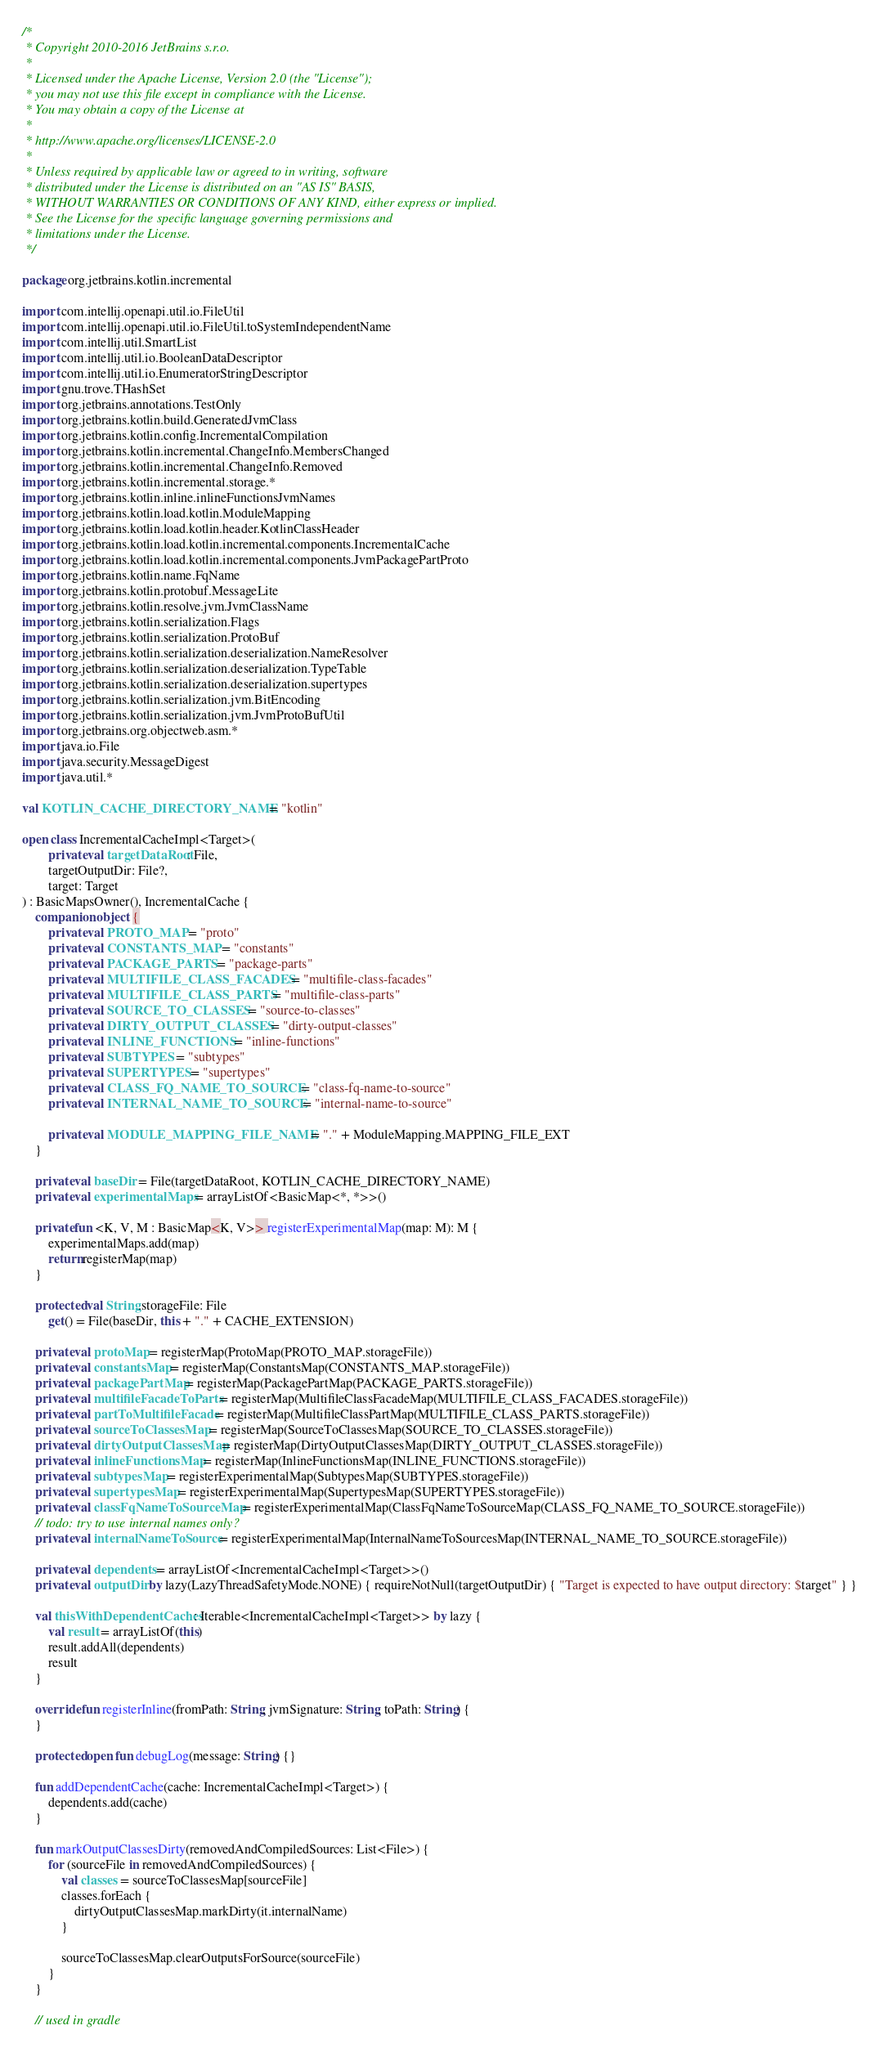Convert code to text. <code><loc_0><loc_0><loc_500><loc_500><_Kotlin_>/*
 * Copyright 2010-2016 JetBrains s.r.o.
 *
 * Licensed under the Apache License, Version 2.0 (the "License");
 * you may not use this file except in compliance with the License.
 * You may obtain a copy of the License at
 *
 * http://www.apache.org/licenses/LICENSE-2.0
 *
 * Unless required by applicable law or agreed to in writing, software
 * distributed under the License is distributed on an "AS IS" BASIS,
 * WITHOUT WARRANTIES OR CONDITIONS OF ANY KIND, either express or implied.
 * See the License for the specific language governing permissions and
 * limitations under the License.
 */

package org.jetbrains.kotlin.incremental

import com.intellij.openapi.util.io.FileUtil
import com.intellij.openapi.util.io.FileUtil.toSystemIndependentName
import com.intellij.util.SmartList
import com.intellij.util.io.BooleanDataDescriptor
import com.intellij.util.io.EnumeratorStringDescriptor
import gnu.trove.THashSet
import org.jetbrains.annotations.TestOnly
import org.jetbrains.kotlin.build.GeneratedJvmClass
import org.jetbrains.kotlin.config.IncrementalCompilation
import org.jetbrains.kotlin.incremental.ChangeInfo.MembersChanged
import org.jetbrains.kotlin.incremental.ChangeInfo.Removed
import org.jetbrains.kotlin.incremental.storage.*
import org.jetbrains.kotlin.inline.inlineFunctionsJvmNames
import org.jetbrains.kotlin.load.kotlin.ModuleMapping
import org.jetbrains.kotlin.load.kotlin.header.KotlinClassHeader
import org.jetbrains.kotlin.load.kotlin.incremental.components.IncrementalCache
import org.jetbrains.kotlin.load.kotlin.incremental.components.JvmPackagePartProto
import org.jetbrains.kotlin.name.FqName
import org.jetbrains.kotlin.protobuf.MessageLite
import org.jetbrains.kotlin.resolve.jvm.JvmClassName
import org.jetbrains.kotlin.serialization.Flags
import org.jetbrains.kotlin.serialization.ProtoBuf
import org.jetbrains.kotlin.serialization.deserialization.NameResolver
import org.jetbrains.kotlin.serialization.deserialization.TypeTable
import org.jetbrains.kotlin.serialization.deserialization.supertypes
import org.jetbrains.kotlin.serialization.jvm.BitEncoding
import org.jetbrains.kotlin.serialization.jvm.JvmProtoBufUtil
import org.jetbrains.org.objectweb.asm.*
import java.io.File
import java.security.MessageDigest
import java.util.*

val KOTLIN_CACHE_DIRECTORY_NAME = "kotlin"

open class IncrementalCacheImpl<Target>(
        private val targetDataRoot: File,
        targetOutputDir: File?,
        target: Target
) : BasicMapsOwner(), IncrementalCache {
    companion object {
        private val PROTO_MAP = "proto"
        private val CONSTANTS_MAP = "constants"
        private val PACKAGE_PARTS = "package-parts"
        private val MULTIFILE_CLASS_FACADES = "multifile-class-facades"
        private val MULTIFILE_CLASS_PARTS = "multifile-class-parts"
        private val SOURCE_TO_CLASSES = "source-to-classes"
        private val DIRTY_OUTPUT_CLASSES = "dirty-output-classes"
        private val INLINE_FUNCTIONS = "inline-functions"
        private val SUBTYPES = "subtypes"
        private val SUPERTYPES = "supertypes"
        private val CLASS_FQ_NAME_TO_SOURCE = "class-fq-name-to-source"
        private val INTERNAL_NAME_TO_SOURCE = "internal-name-to-source"

        private val MODULE_MAPPING_FILE_NAME = "." + ModuleMapping.MAPPING_FILE_EXT
    }

    private val baseDir = File(targetDataRoot, KOTLIN_CACHE_DIRECTORY_NAME)
    private val experimentalMaps = arrayListOf<BasicMap<*, *>>()

    private fun <K, V, M : BasicMap<K, V>> registerExperimentalMap(map: M): M {
        experimentalMaps.add(map)
        return registerMap(map)
    }

    protected val String.storageFile: File
        get() = File(baseDir, this + "." + CACHE_EXTENSION)

    private val protoMap = registerMap(ProtoMap(PROTO_MAP.storageFile))
    private val constantsMap = registerMap(ConstantsMap(CONSTANTS_MAP.storageFile))
    private val packagePartMap = registerMap(PackagePartMap(PACKAGE_PARTS.storageFile))
    private val multifileFacadeToParts = registerMap(MultifileClassFacadeMap(MULTIFILE_CLASS_FACADES.storageFile))
    private val partToMultifileFacade = registerMap(MultifileClassPartMap(MULTIFILE_CLASS_PARTS.storageFile))
    private val sourceToClassesMap = registerMap(SourceToClassesMap(SOURCE_TO_CLASSES.storageFile))
    private val dirtyOutputClassesMap = registerMap(DirtyOutputClassesMap(DIRTY_OUTPUT_CLASSES.storageFile))
    private val inlineFunctionsMap = registerMap(InlineFunctionsMap(INLINE_FUNCTIONS.storageFile))
    private val subtypesMap = registerExperimentalMap(SubtypesMap(SUBTYPES.storageFile))
    private val supertypesMap = registerExperimentalMap(SupertypesMap(SUPERTYPES.storageFile))
    private val classFqNameToSourceMap = registerExperimentalMap(ClassFqNameToSourceMap(CLASS_FQ_NAME_TO_SOURCE.storageFile))
    // todo: try to use internal names only?
    private val internalNameToSource = registerExperimentalMap(InternalNameToSourcesMap(INTERNAL_NAME_TO_SOURCE.storageFile))

    private val dependents = arrayListOf<IncrementalCacheImpl<Target>>()
    private val outputDir by lazy(LazyThreadSafetyMode.NONE) { requireNotNull(targetOutputDir) { "Target is expected to have output directory: $target" } }

    val thisWithDependentCaches: Iterable<IncrementalCacheImpl<Target>> by lazy {
        val result = arrayListOf(this)
        result.addAll(dependents)
        result
    }

    override fun registerInline(fromPath: String, jvmSignature: String, toPath: String) {
    }

    protected open fun debugLog(message: String) {}

    fun addDependentCache(cache: IncrementalCacheImpl<Target>) {
        dependents.add(cache)
    }

    fun markOutputClassesDirty(removedAndCompiledSources: List<File>) {
        for (sourceFile in removedAndCompiledSources) {
            val classes = sourceToClassesMap[sourceFile]
            classes.forEach {
                dirtyOutputClassesMap.markDirty(it.internalName)
            }

            sourceToClassesMap.clearOutputsForSource(sourceFile)
        }
    }

    // used in gradle</code> 